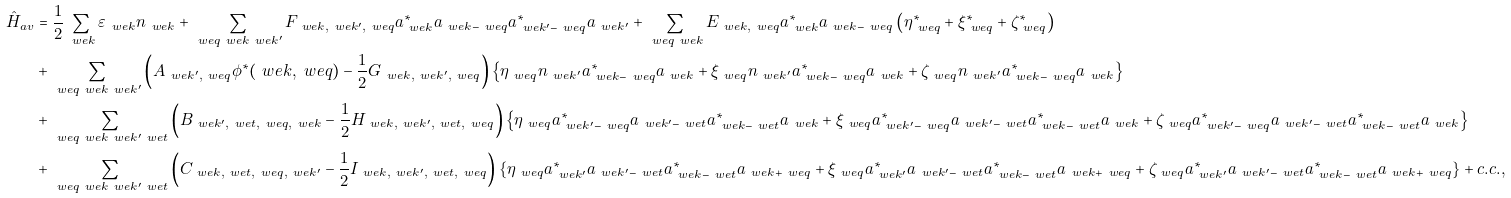Convert formula to latex. <formula><loc_0><loc_0><loc_500><loc_500>\hat { H } _ { a v } & = \frac { 1 } { 2 } \sum _ { \ w e { k } } \varepsilon _ { \ w e { k } } n _ { \ w e { k } } + \sum _ { \ w e { q } \ w e { k } \ w e { k ^ { \prime } } } F _ { \ w e { k } , \ w e { k ^ { \prime } } , \ w e { q } } a _ { \ w e { k } } ^ { \ast } a _ { \ w e { k } - \ w e { q } } a _ { \ w e { k ^ { \prime } } - \ w e { q } } ^ { \ast } a _ { \ w e { k ^ { \prime } } } + \sum _ { \ w e { q } \ w e { k } } E _ { \ w e { k } , \ w e { q } } a _ { \ w e { k } } ^ { \ast } a _ { \ w e { k } - \ w e { q } } \left ( \eta _ { \ w e { q } } ^ { \ast } + \xi _ { \ w e { q } } ^ { \ast } + \zeta _ { \ w e { q } } ^ { \ast } \right ) \\ & + \sum _ { \ w e { q } \ w e { k } \ w e { k ^ { \prime } } } \left ( A _ { \ w e { k ^ { \prime } } , \ w e { q } } \phi ^ { \ast } ( \ w e { k } , \ w e { q } ) - \frac { 1 } { 2 } G _ { \ w e { k } , \ w e { k ^ { \prime } } , \ w e { q } } \right ) \left \{ \eta _ { \ w e { q } } n _ { \ w e { k ^ { \prime } } } a _ { \ w e { k } - \ w e { q } } ^ { \ast } a _ { \ w e { k } } + \xi _ { \ w e { q } } n _ { \ w e { k ^ { \prime } } } a _ { \ w e { k } - \ w e { q } } ^ { \ast } a _ { \ w e { k } } + \zeta _ { \ w e { q } } n _ { \ w e { k ^ { \prime } } } a _ { \ w e { k } - \ w e { q } } ^ { \ast } a _ { \ w e { k } } \right \} \\ & + \sum _ { \ w e { q } \ w e { k } \ w e { k ^ { \prime } } \ w e { t } } \left ( B _ { \ w e { k ^ { \prime } } , \ w e { t } , \ w e { q } , \ w e { k } } - \frac { 1 } { 2 } H _ { \ w e { k } , \ w e { k ^ { \prime } } , \ w e { t } , \ w e { q } } \right ) \left \{ \eta _ { \ w e { q } } a _ { \ w e { k ^ { \prime } } - \ w e { q } } ^ { \ast } a _ { \ w e { k ^ { \prime } } - \ w e { t } } a _ { \ w e { k } - \ w e { t } } ^ { \ast } a _ { \ w e { k } } + \xi _ { \ w e { q } } a _ { \ w e { k ^ { \prime } } - \ w e { q } } ^ { \ast } a _ { \ w e { k ^ { \prime } } - \ w e { t } } a _ { \ w e { k } - \ w e { t } } ^ { \ast } a _ { \ w e { k } } + \zeta _ { \ w e { q } } a _ { \ w e { k ^ { \prime } } - \ w e { q } } ^ { \ast } a _ { \ w e { k ^ { \prime } } - \ w e { t } } a _ { \ w e { k } - \ w e { t } } ^ { \ast } a _ { \ w e { k } } \right \} \\ & + \sum _ { \ w e { q } \ w e { k } \ w e { k ^ { \prime } } \ w e { t } } \left ( C _ { \ w e { k } , \ w e { t } , \ w e { q } , \ w e { k ^ { \prime } } } - \frac { 1 } { 2 } I _ { \ w e { k } , \ w e { k ^ { \prime } } , \ w e { t } , \ w e { q } } \right ) \left \{ \eta _ { \ w e { q } } a _ { \ w e { k ^ { \prime } } } ^ { \ast } a _ { \ w e { k ^ { \prime } } - \ w e { t } } a _ { \ w e { k } - \ w e { t } } ^ { \ast } a _ { \ w e { k } + \ w e { q } } + \xi _ { \ w e { q } } a _ { \ w e { k ^ { \prime } } } ^ { \ast } a _ { \ w e { k ^ { \prime } } - \ w e { t } } a _ { \ w e { k } - \ w e { t } } ^ { \ast } a _ { \ w e { k } + \ w e { q } } + \zeta _ { \ w e { q } } a _ { \ w e { k ^ { \prime } } } ^ { \ast } a _ { \ w e { k ^ { \prime } } - \ w e { t } } a _ { \ w e { k } - \ w e { t } } ^ { \ast } a _ { \ w e { k } + \ w e { q } } \right \} + c . c . , \\</formula> 